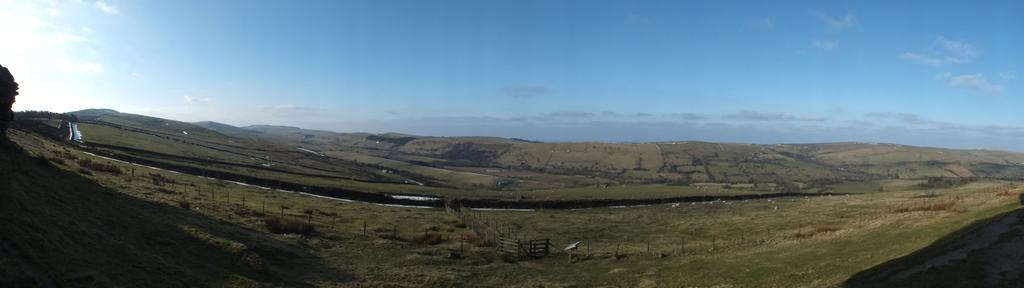What type of landscape is depicted in the image? The image features grasslands. What type of structure can be seen in the image? There is a wooden fence in the image. What color is the sky in the image? The sky is blue in the image. What can be seen in the sky in the background of the image? Clouds are visible in the sky in the background of the image. What type of glue is being used to hold the wall together in the image? There is no wall present in the image, and therefore no glue or construction materials can be observed. How many pears are visible on the grasslands in the image? There are no pears present in the image; the landscape features grasslands and a wooden fence. 